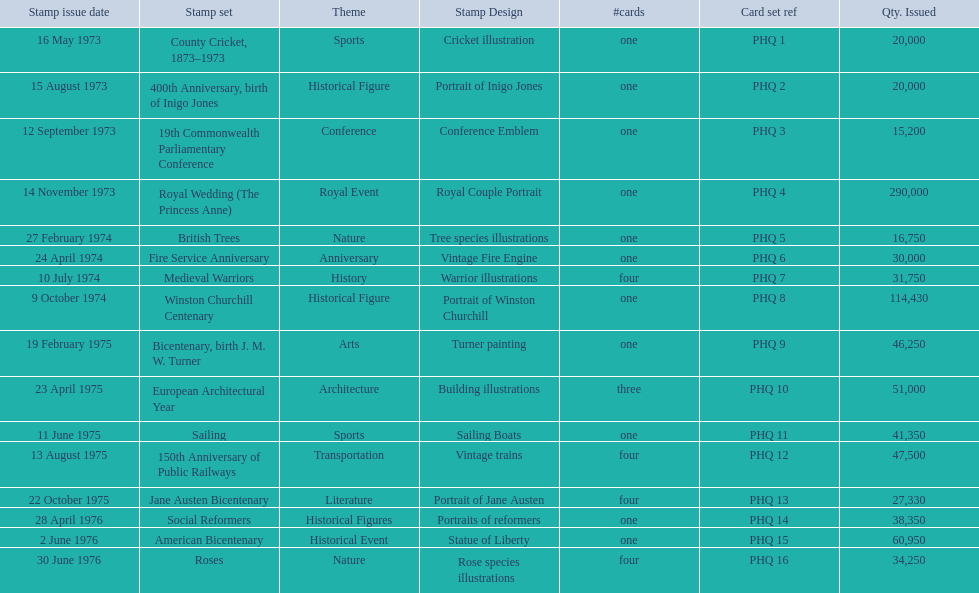Which stamp sets had three or more cards? Medieval Warriors, European Architectural Year, 150th Anniversary of Public Railways, Jane Austen Bicentenary, Roses. Of those, which one only has three cards? European Architectural Year. 